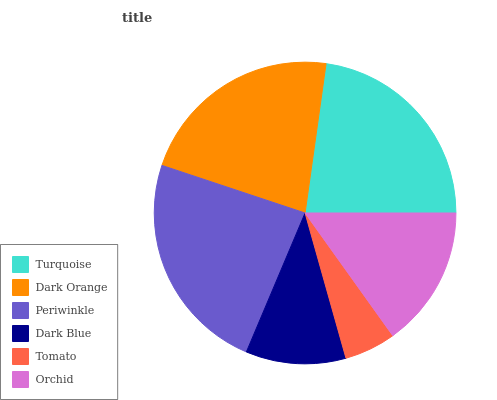Is Tomato the minimum?
Answer yes or no. Yes. Is Periwinkle the maximum?
Answer yes or no. Yes. Is Dark Orange the minimum?
Answer yes or no. No. Is Dark Orange the maximum?
Answer yes or no. No. Is Turquoise greater than Dark Orange?
Answer yes or no. Yes. Is Dark Orange less than Turquoise?
Answer yes or no. Yes. Is Dark Orange greater than Turquoise?
Answer yes or no. No. Is Turquoise less than Dark Orange?
Answer yes or no. No. Is Dark Orange the high median?
Answer yes or no. Yes. Is Orchid the low median?
Answer yes or no. Yes. Is Dark Blue the high median?
Answer yes or no. No. Is Turquoise the low median?
Answer yes or no. No. 